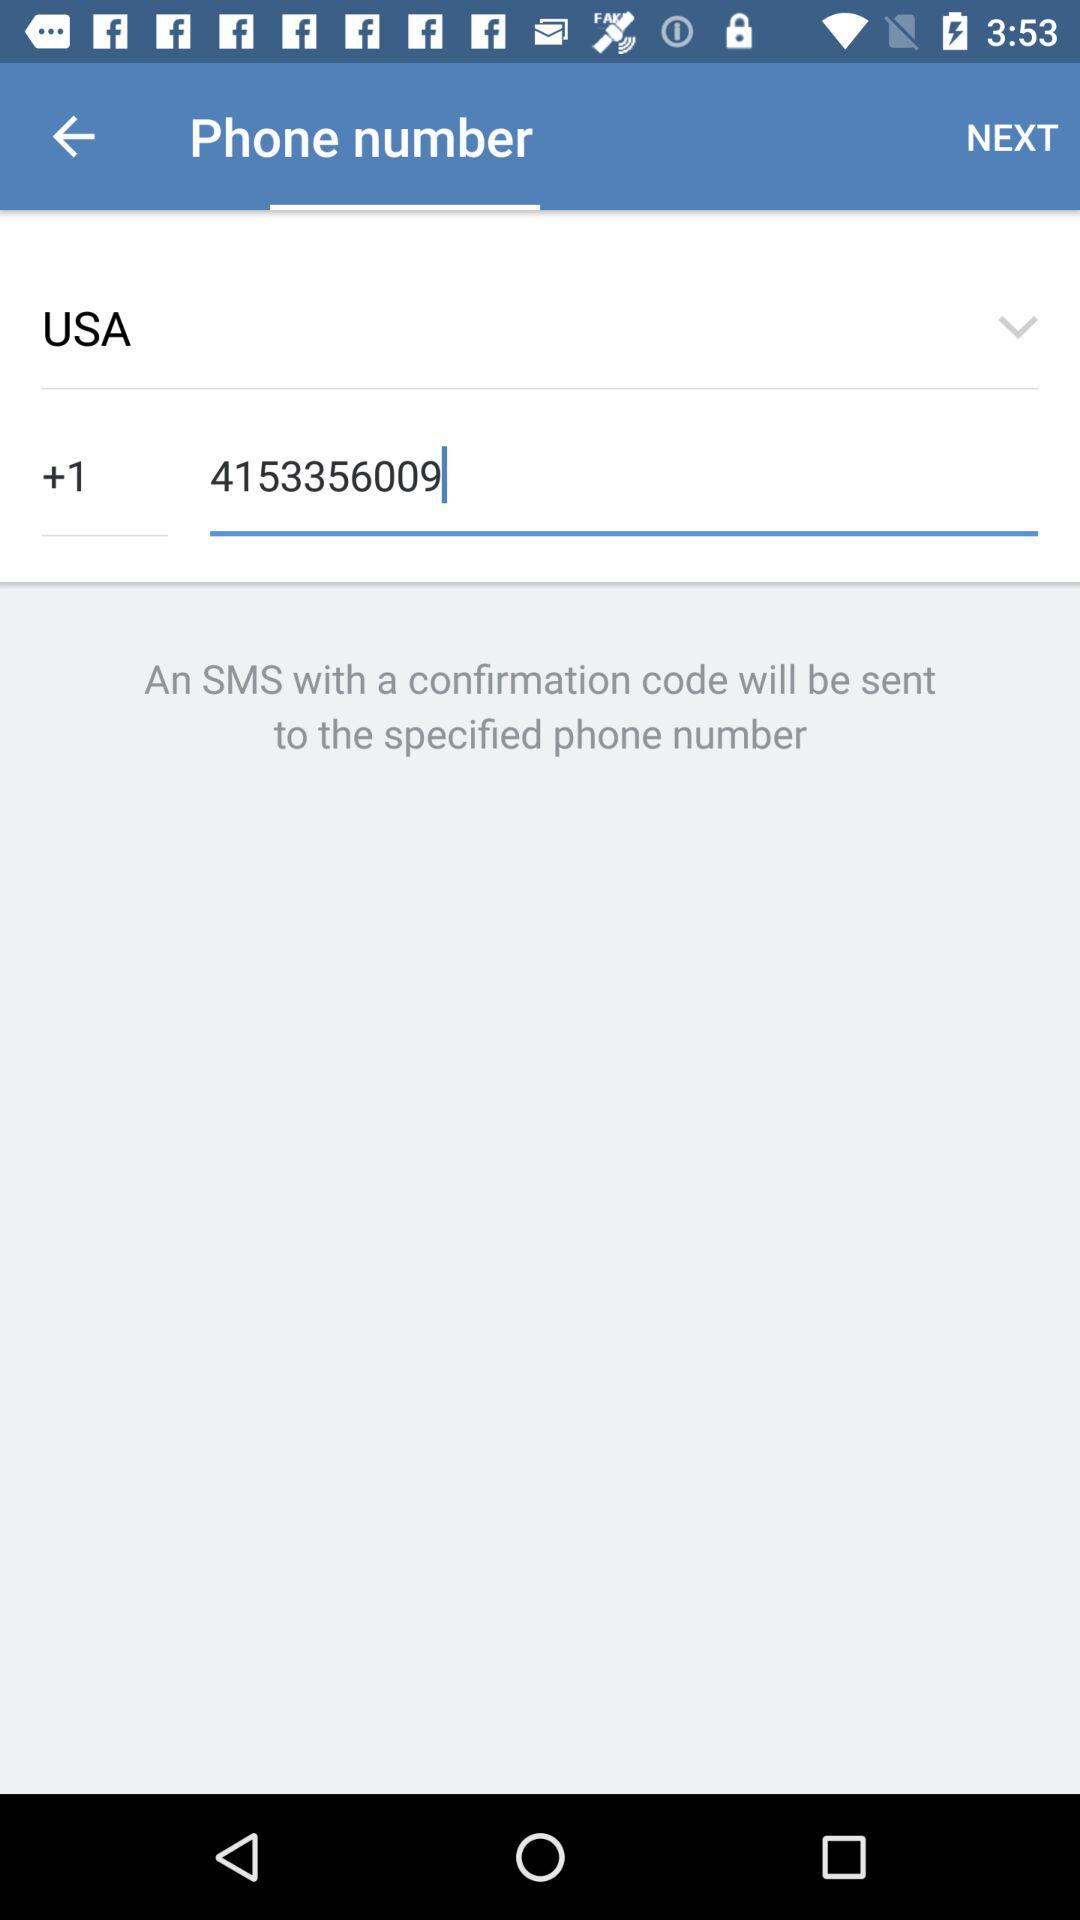What is the phone number? The phone number is 4153356009. 